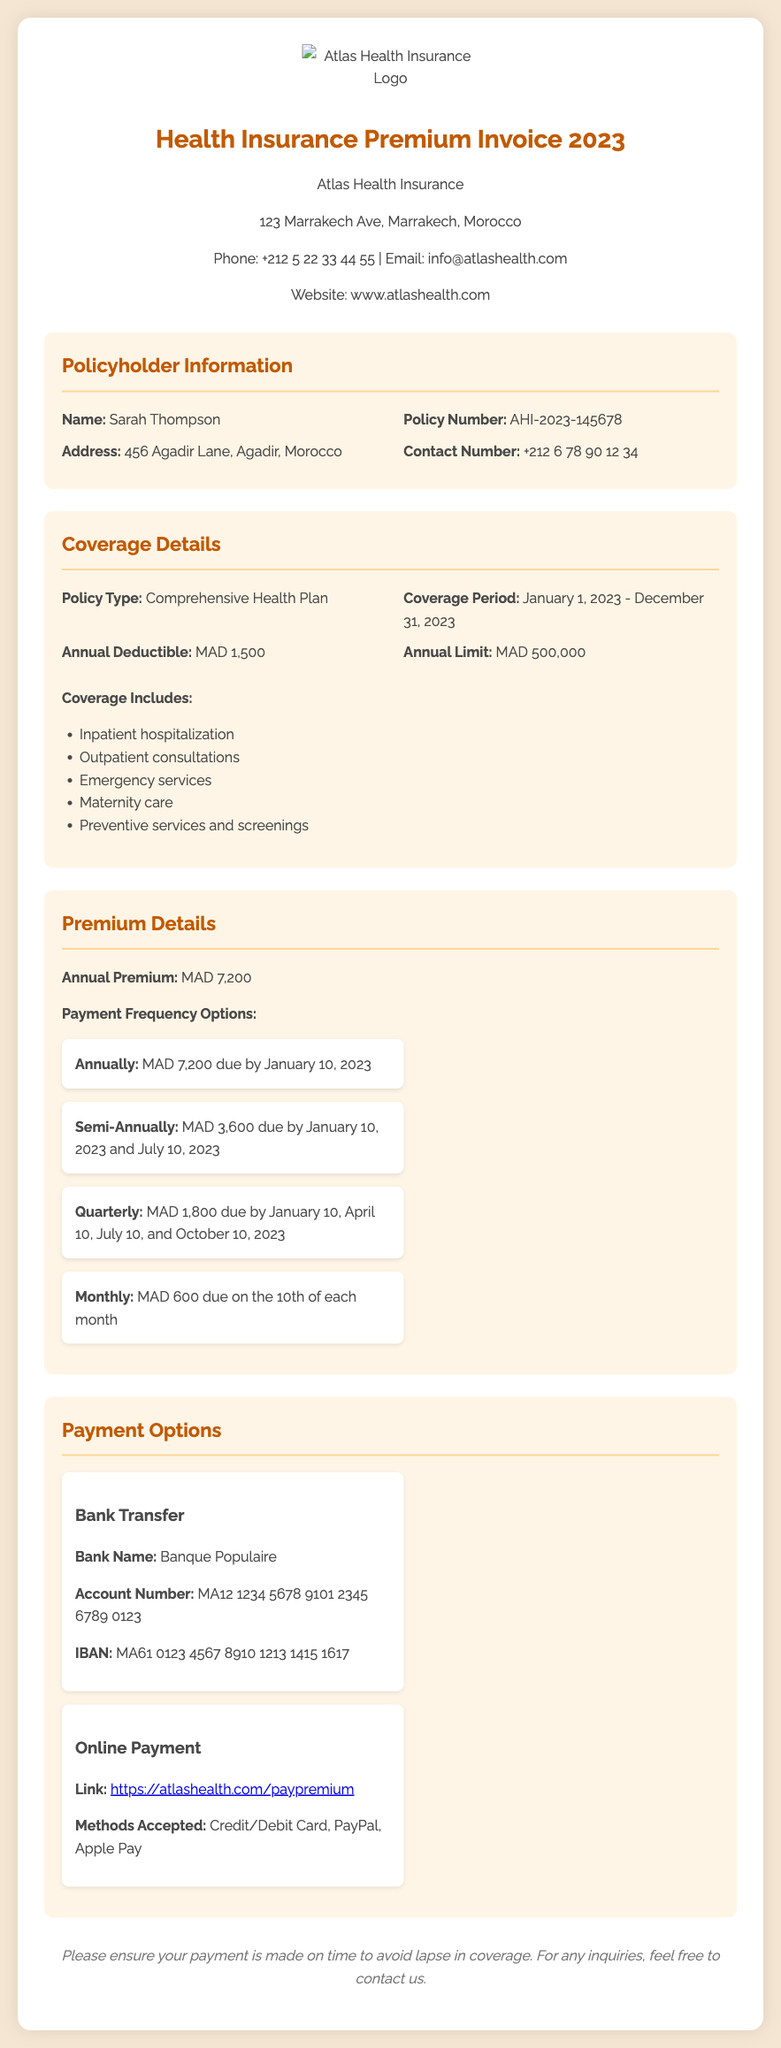What is the name of the policyholder? The name of the policyholder is located in the Policyholder Information section of the document.
Answer: Sarah Thompson What is the annual deductible? The annual deductible is mentioned under the Coverage Details section.
Answer: MAD 1,500 What is the policy number? The policy number can be found in the Policyholder Information section.
Answer: AHI-2023-145678 When is the annual premium due? The due date for the annual premium is specified in the Premium Details section.
Answer: January 10, 2023 How much is the annual premium? The annual premium amount is indicated in the Premium Details section.
Answer: MAD 7,200 What coverage is included? The coverage details are listed under the Coverage Includes section.
Answer: Inpatient hospitalization, Outpatient consultations, Emergency services, Maternity care, Preventive services and screenings How many payment frequency options are available? The document lists different payment frequency options in the Premium Details section.
Answer: Four What is the bank name for payment? The bank name is provided in the Payment Options section.
Answer: Banque Populaire What methods are accepted for online payment? The methods accepted for online payment are listed under the Payment Options section.
Answer: Credit/Debit Card, PayPal, Apple Pay 